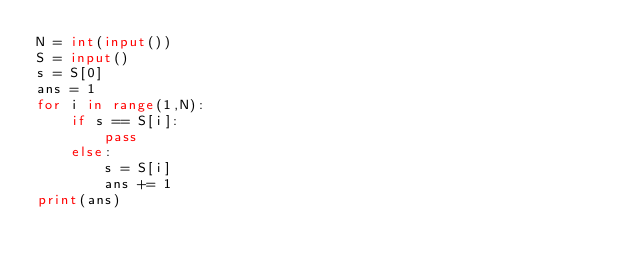<code> <loc_0><loc_0><loc_500><loc_500><_Python_>N = int(input())
S = input()
s = S[0]
ans = 1
for i in range(1,N):
    if s == S[i]:
        pass
    else:
        s = S[i]
        ans += 1
print(ans)
</code> 